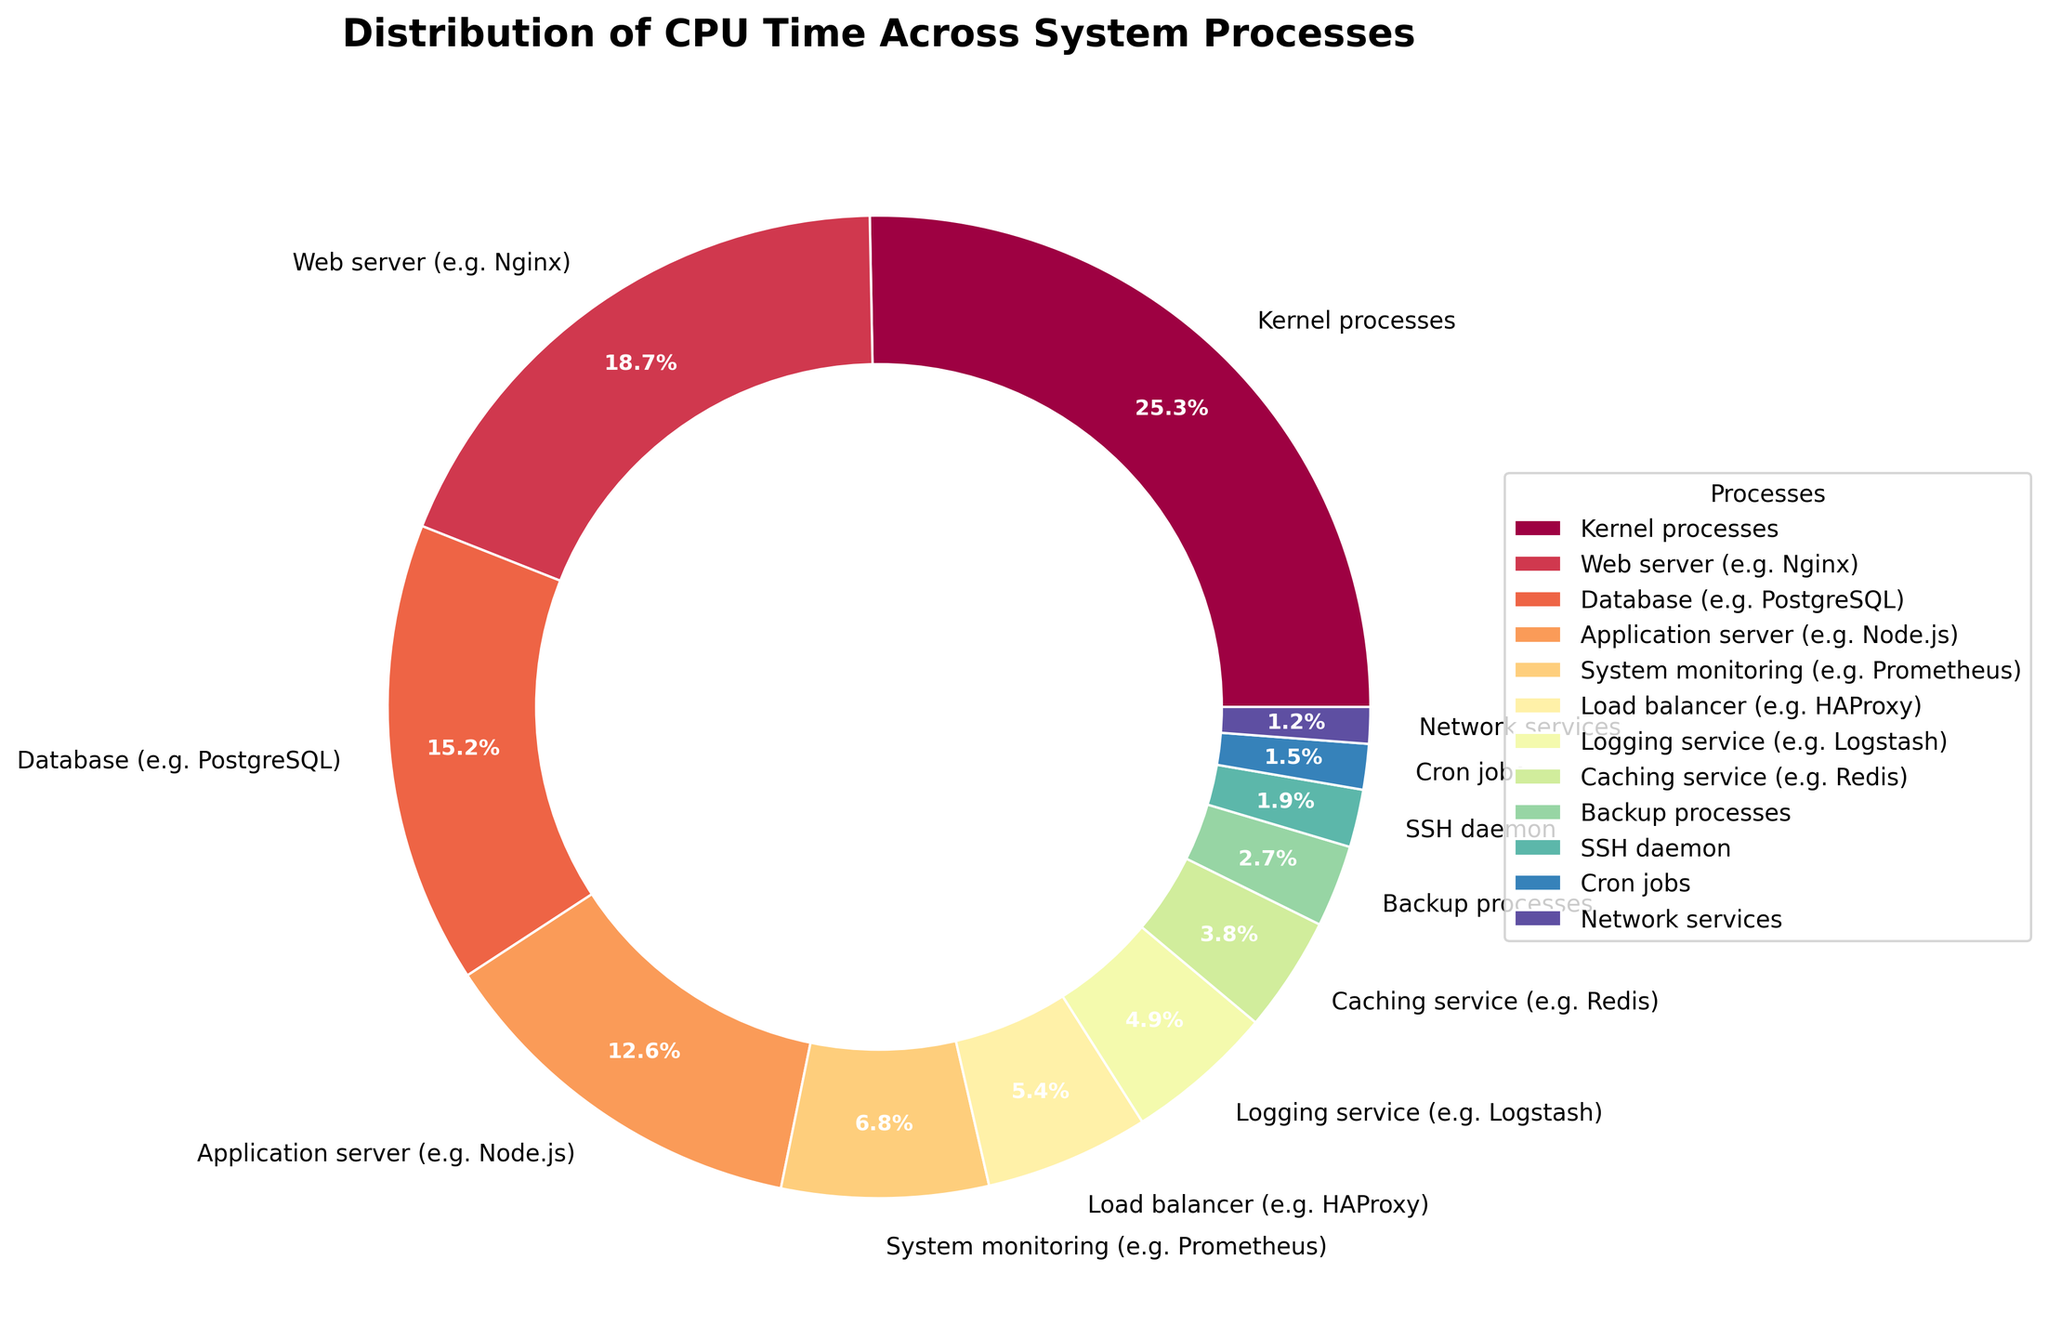Which process uses the highest percentage of CPU time? By looking at the pie chart, we can identify the largest slice, which should correspond to "Kernel processes" at 25.3%.
Answer: Kernel processes Which two processes together use roughly the same CPU time as the Kernel processes? To answer this, sum up the CPU percentages of the second and third largest slices; Web server (18.7%) + Database (15.2%) = 33.9%, which is close but not equal. The Application server and Web server sum up to 12.6% + 18.7% = 31.3%, which is also not enough. However, 15.2% + 12.6% ≈ 27.8%, but still not quite exact. The closest match would be Web server and System Monitoring, summing to 18.7% + 6.8% = 25.5%.
Answer: Web server and System Monitoring Which processes use less than 5% of CPU time individually? Look for slices that represent less than 5% of CPU time. These include Caching service (3.8%), Backup processes (2.7%), SSH daemon (1.9%), Cron jobs (1.5%), and Network services (1.2%).
Answer: Caching service, Backup processes, SSH daemon, Cron jobs, Network services Compare the CPU usage of the Load balancer with that of Caching service. Which one uses more CPU and by how much? The Load balancer uses 5.4% of the CPU time, and the Caching service uses 3.8%. The difference in usage is 5.4% - 3.8% = 1.6%.
Answer: Load balancer by 1.6% What is the total CPU time percentage used by services related to network operations? Summing up the percentages for Web server (18.7%), Load balancer (5.4%), and Network services (1.2%): 18.7% + 5.4% + 1.2% = 25.3%
Answer: 25.3% If the percentages are added up for Database, Application server, and Load balancer, does it exceed Web server usage? Sum CPU time of Database (15.2%), Application server (12.6%), and Load balancer (5.4%): 15.2% + 12.6% + 5.4% = 33.2%, which does exceed the Web server (18.7%).
Answer: Yes, it exceeds How does the CPU time usage of the SSH daemon compare to Cron jobs? The SSH daemon uses 1.9% of CPU time, while Cron jobs use 1.5%. The SSH daemon uses more by 1.9% - 1.5% = 0.4%.
Answer: SSH daemon by 0.4% Which process category, System monitoring or Logging service, has higher CPU usage, and by what percentage? System monitoring uses 6.8% of CPU, while Logging service uses 4.9%. The difference is 6.8% - 4.9% = 1.9%.
Answer: System monitoring by 1.9% 